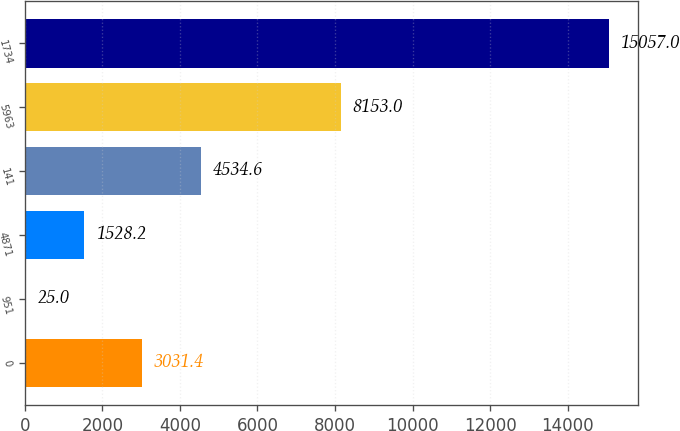<chart> <loc_0><loc_0><loc_500><loc_500><bar_chart><fcel>0<fcel>951<fcel>4871<fcel>141<fcel>5963<fcel>1734<nl><fcel>3031.4<fcel>25<fcel>1528.2<fcel>4534.6<fcel>8153<fcel>15057<nl></chart> 